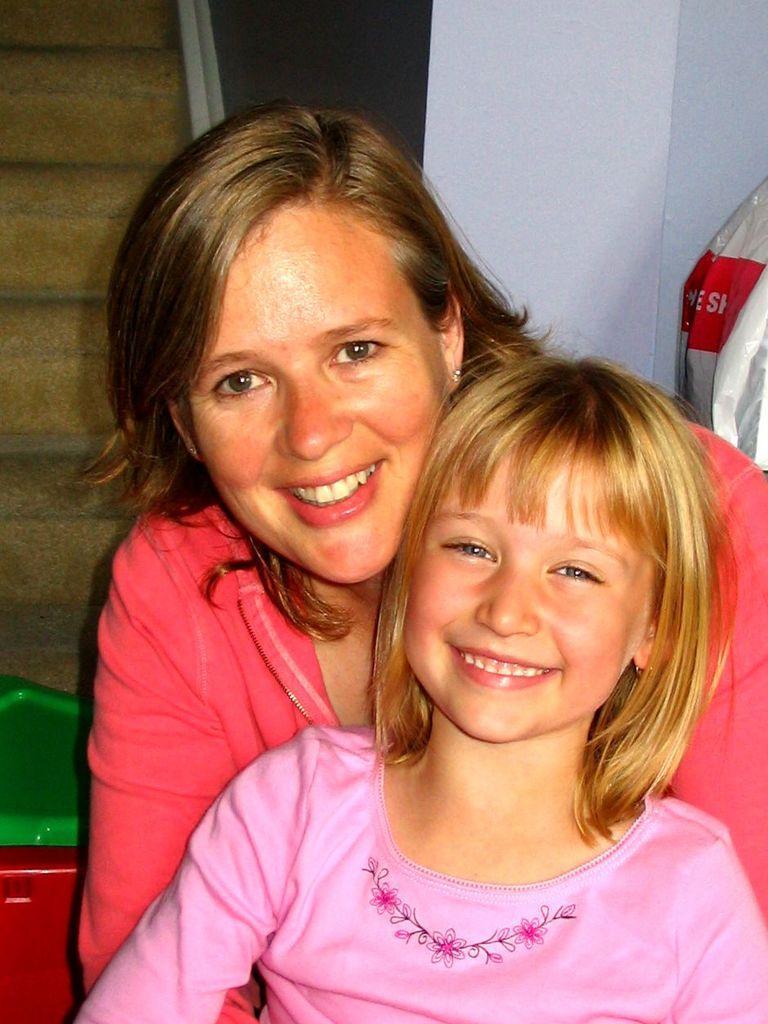How would you summarize this image in a sentence or two? In this image in the foreground there is one woman and one girl who are smiling, and in the background there is a wall, plastic cover and some stairs. At the bottom there is some object. 